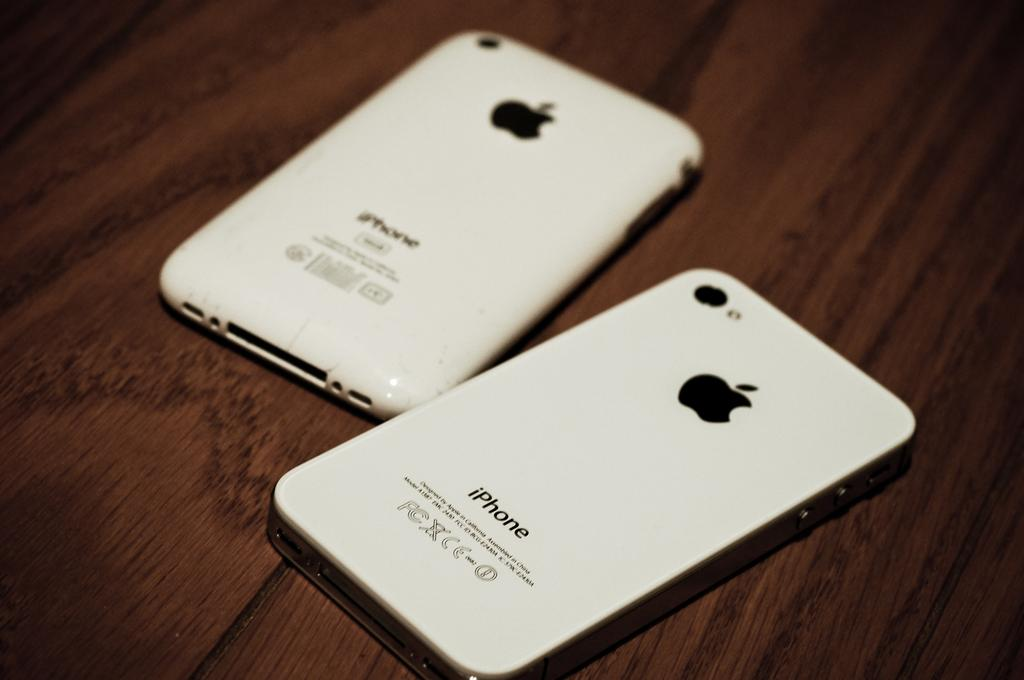What type of table is in the image? There is a wooden table in the image. What electronic devices are on the table? There are two iPhones on the table. What color are the iPhones? The iPhones are white in color. What symbol is present on the iPhones? The iPhones have the Apple symbol. What type of bean is being cooked in the stew on the table? There is no stew or bean present in the image; it only features a wooden table and two iPhones. 